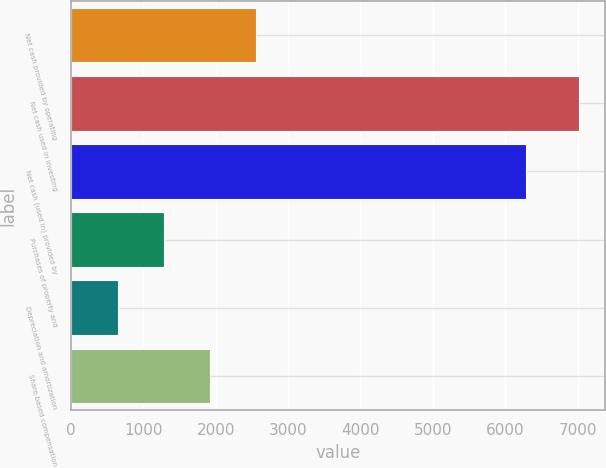Convert chart. <chart><loc_0><loc_0><loc_500><loc_500><bar_chart><fcel>Net cash provided by operating<fcel>Net cash used in investing<fcel>Net cash (used in) provided by<fcel>Purchases of property and<fcel>Depreciation and amortization<fcel>Share-based compensation<nl><fcel>2561.5<fcel>7024<fcel>6283<fcel>1286.5<fcel>649<fcel>1924<nl></chart> 